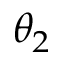Convert formula to latex. <formula><loc_0><loc_0><loc_500><loc_500>\theta _ { 2 }</formula> 